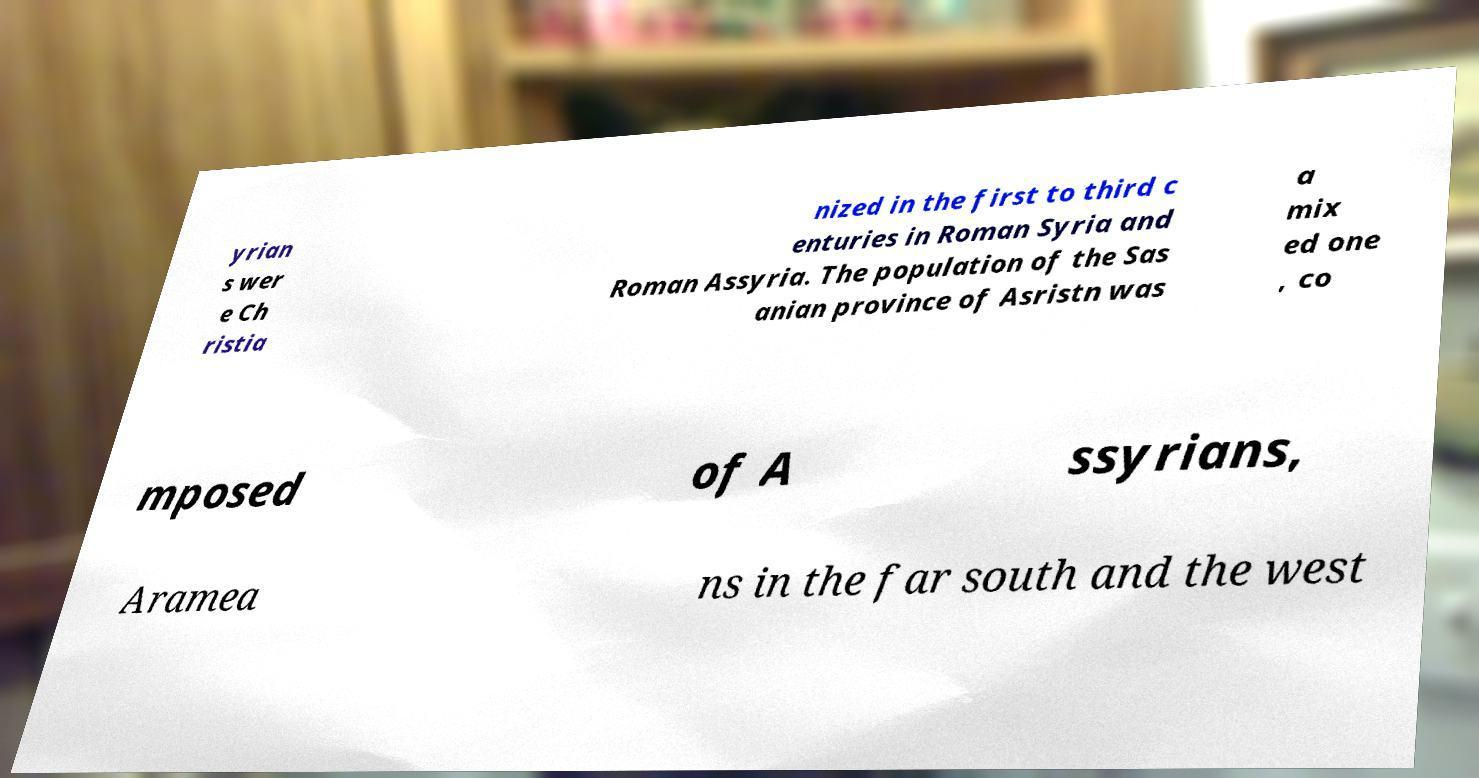Could you extract and type out the text from this image? yrian s wer e Ch ristia nized in the first to third c enturies in Roman Syria and Roman Assyria. The population of the Sas anian province of Asristn was a mix ed one , co mposed of A ssyrians, Aramea ns in the far south and the west 